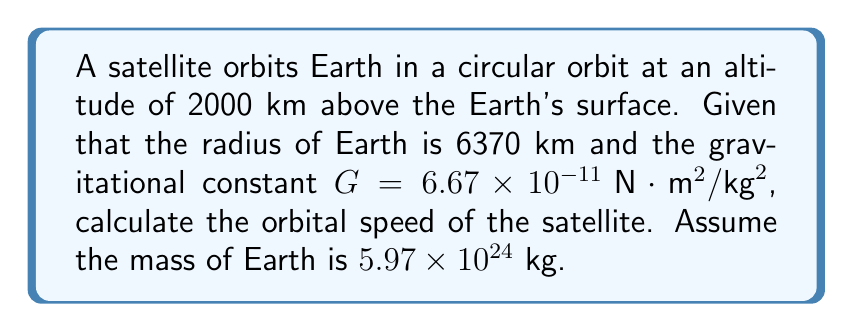Show me your answer to this math problem. Let's approach this step-by-step:

1) First, we need to determine the radius of the orbit. This is the sum of Earth's radius and the altitude of the satellite:
   
   $r = 6370 \text{ km} + 2000 \text{ km} = 8370 \text{ km} = 8.37 \times 10^6 \text{ m}$

2) For a circular orbit, the centripetal force is provided by gravity. We can equate these forces:

   $$F_c = F_g$$
   $$\frac{mv^2}{r} = \frac{GMm}{r^2}$$

   Where $m$ is the mass of the satellite, $v$ is its orbital speed, $M$ is the mass of Earth, and $r$ is the orbital radius.

3) The mass of the satellite $m$ cancels out:

   $$\frac{v^2}{r} = \frac{GM}{r^2}$$

4) We can now solve for $v$:

   $$v^2 = \frac{GM}{r}$$
   $$v = \sqrt{\frac{GM}{r}}$$

5) Now we can substitute our known values:

   $$v = \sqrt{\frac{(6.67 \times 10^{-11})(5.97 \times 10^{24})}{8.37 \times 10^6}}$$

6) Calculating this:

   $$v = 7.61 \times 10^3 \text{ m/s}$$

This is approximately 7.61 km/s.
Answer: 7.61 km/s 